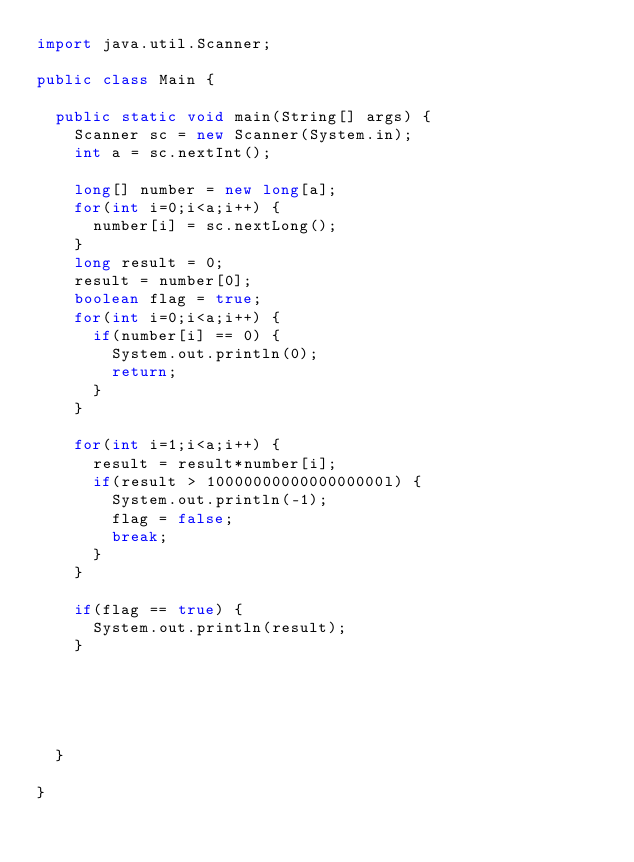<code> <loc_0><loc_0><loc_500><loc_500><_Java_>import java.util.Scanner;

public class Main {

	public static void main(String[] args) {
		Scanner sc = new Scanner(System.in);
		int a = sc.nextInt();
		
		long[] number = new long[a];
		for(int i=0;i<a;i++) {
			number[i] = sc.nextLong();
		}
		long result = 0;
		result = number[0];
		boolean flag = true;
		for(int i=0;i<a;i++) {
			if(number[i] == 0) {
				System.out.println(0);
				return;
			}
		}
		
		for(int i=1;i<a;i++) {
			result = result*number[i];
			if(result > 1000000000000000000l) {
				System.out.println(-1);
				flag = false;
				break;
			}
		}
		
		if(flag == true) {
			System.out.println(result);
		}
		
		
			
		

	}

}
</code> 